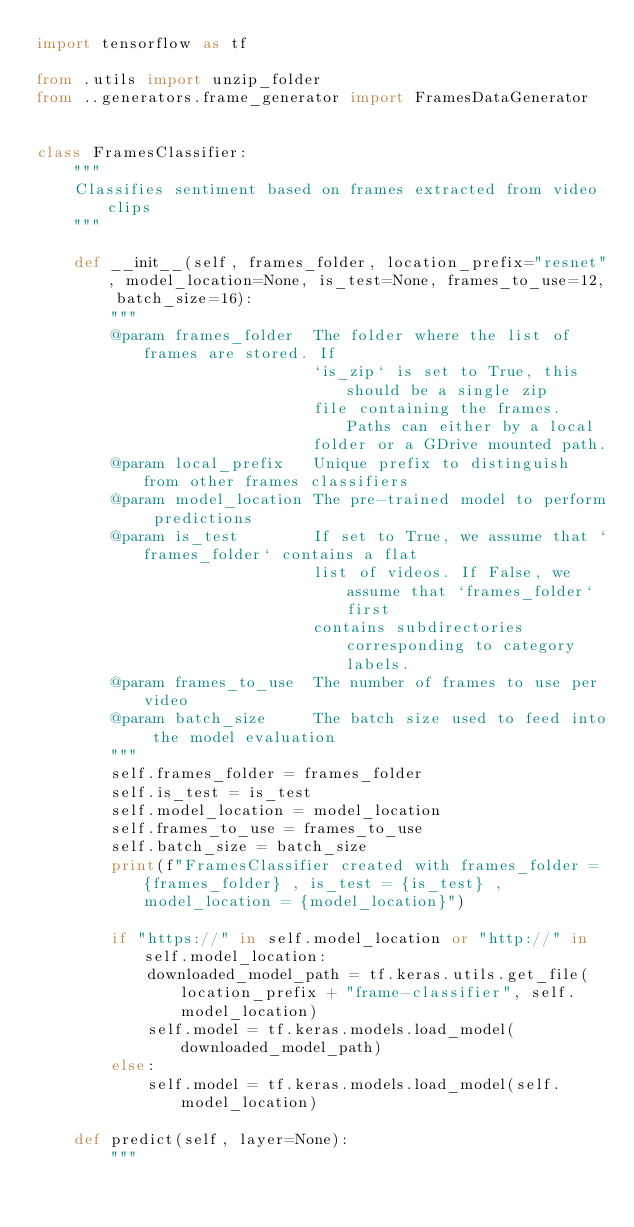<code> <loc_0><loc_0><loc_500><loc_500><_Python_>import tensorflow as tf

from .utils import unzip_folder
from ..generators.frame_generator import FramesDataGenerator


class FramesClassifier:
    """
    Classifies sentiment based on frames extracted from video clips
    """

    def __init__(self, frames_folder, location_prefix="resnet", model_location=None, is_test=None, frames_to_use=12, batch_size=16):
        """
        @param frames_folder  The folder where the list of frames are stored. If
                              `is_zip` is set to True, this should be a single zip
                              file containing the frames. Paths can either by a local
                              folder or a GDrive mounted path.
        @param local_prefix   Unique prefix to distinguish from other frames classifiers
        @param model_location The pre-trained model to perform predictions
        @param is_test        If set to True, we assume that `frames_folder` contains a flat
                              list of videos. If False, we assume that `frames_folder` first
                              contains subdirectories corresponding to category labels.
        @param frames_to_use  The number of frames to use per video
        @param batch_size     The batch size used to feed into the model evaluation
        """
        self.frames_folder = frames_folder
        self.is_test = is_test
        self.model_location = model_location
        self.frames_to_use = frames_to_use
        self.batch_size = batch_size
        print(f"FramesClassifier created with frames_folder = {frames_folder} , is_test = {is_test} , model_location = {model_location}")

        if "https://" in self.model_location or "http://" in self.model_location:
            downloaded_model_path = tf.keras.utils.get_file(location_prefix + "frame-classifier", self.model_location)
            self.model = tf.keras.models.load_model(downloaded_model_path)
        else:
            self.model = tf.keras.models.load_model(self.model_location)

    def predict(self, layer=None):
        """</code> 